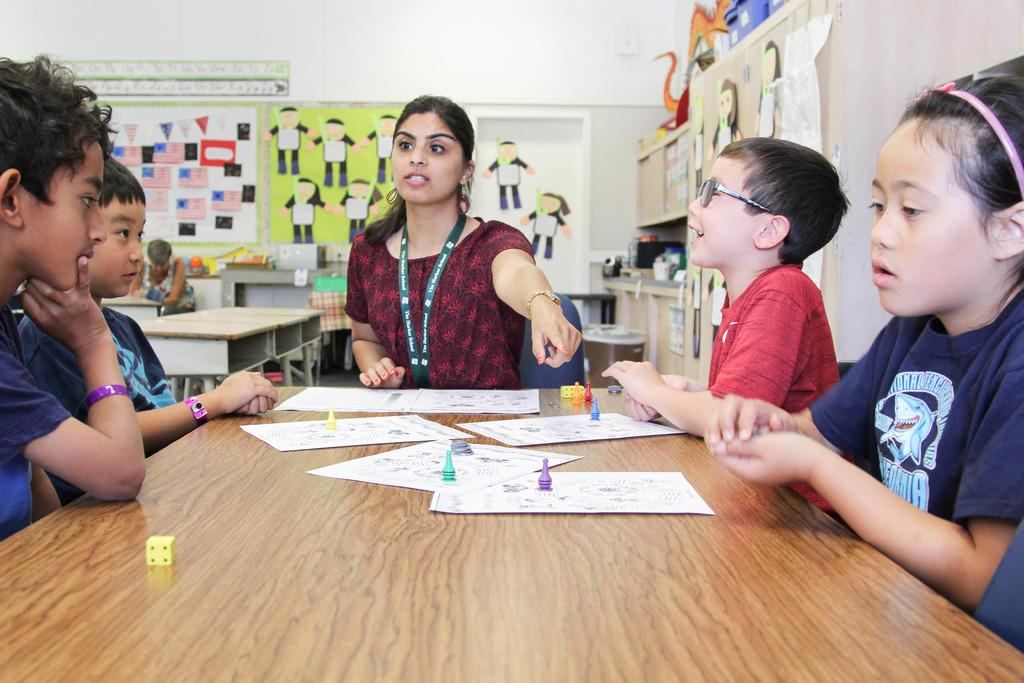What are the kids doing in the image? The kids are seated on chairs in the image. Can you describe the woman in the image? The woman is wearing an ID card in the image. What is on the table in the image? There are papers and dice on the table in the image. What can be seen on the wall in the image? There are posters on the wall in the image. Is there anyone else seated in the image? Yes, there is a woman seated in the image. What type of music is being played in the image? There is no indication of music being played in the image. How does the woman's stomach feel in the image? There is no information about the woman's stomach in the image. 